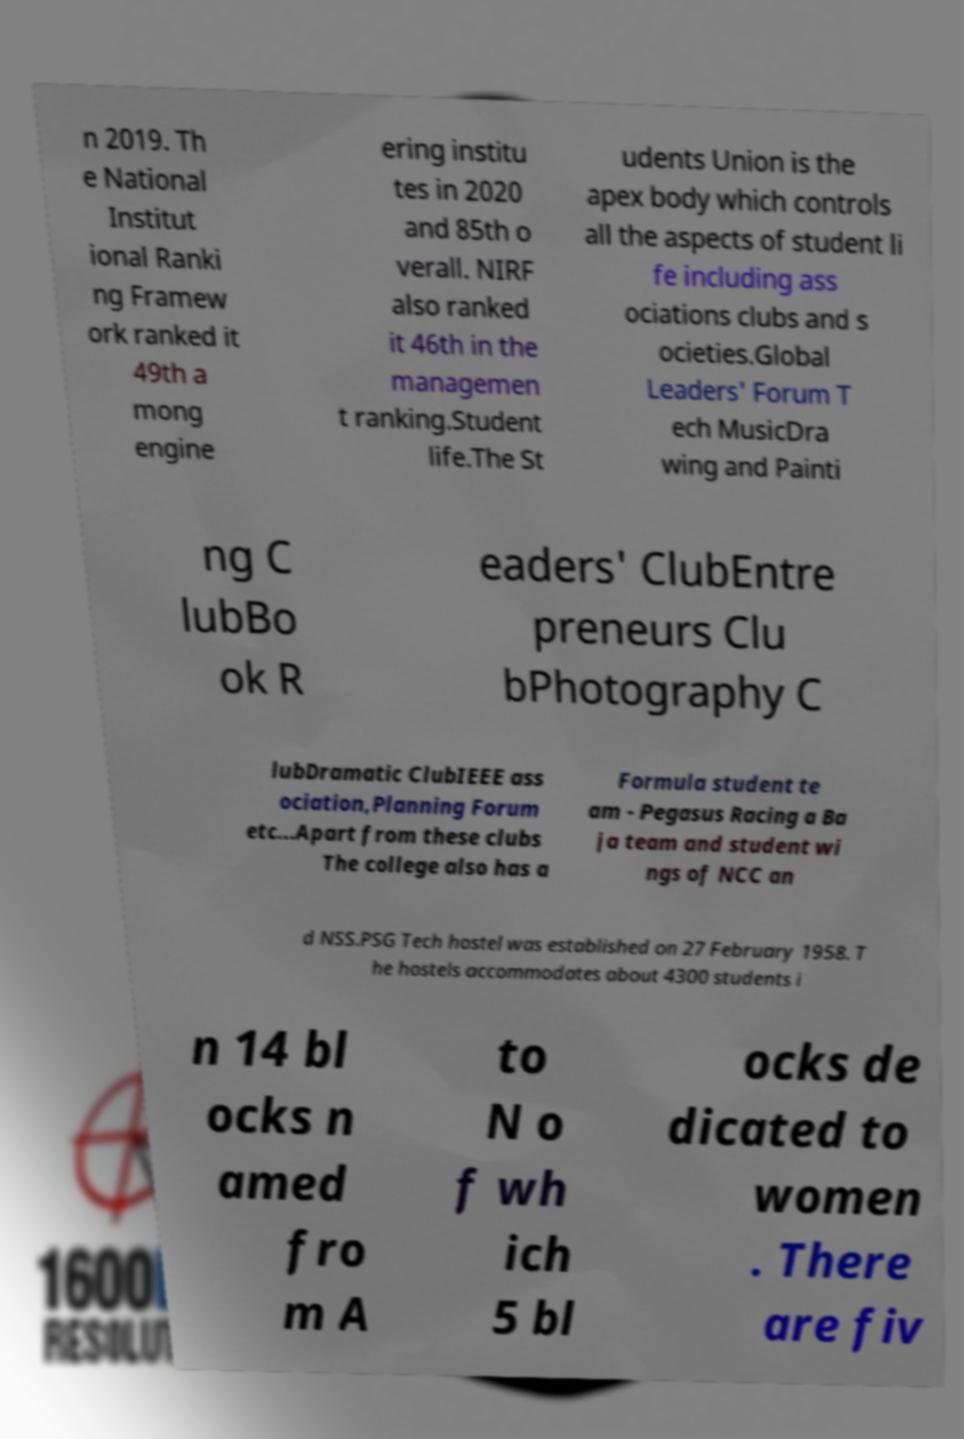Could you extract and type out the text from this image? n 2019. Th e National Institut ional Ranki ng Framew ork ranked it 49th a mong engine ering institu tes in 2020 and 85th o verall. NIRF also ranked it 46th in the managemen t ranking.Student life.The St udents Union is the apex body which controls all the aspects of student li fe including ass ociations clubs and s ocieties.Global Leaders' Forum T ech MusicDra wing and Painti ng C lubBo ok R eaders' ClubEntre preneurs Clu bPhotography C lubDramatic ClubIEEE ass ociation,Planning Forum etc...Apart from these clubs The college also has a Formula student te am - Pegasus Racing a Ba ja team and student wi ngs of NCC an d NSS.PSG Tech hostel was established on 27 February 1958. T he hostels accommodates about 4300 students i n 14 bl ocks n amed fro m A to N o f wh ich 5 bl ocks de dicated to women . There are fiv 